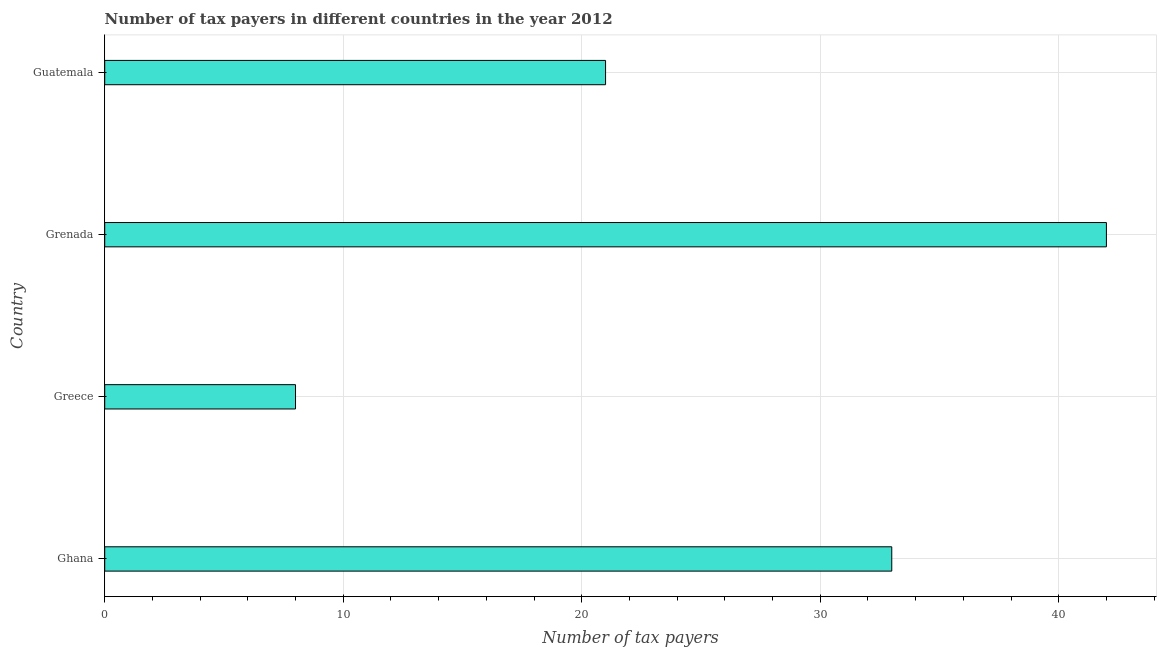What is the title of the graph?
Provide a short and direct response. Number of tax payers in different countries in the year 2012. What is the label or title of the X-axis?
Your response must be concise. Number of tax payers. What is the label or title of the Y-axis?
Provide a succinct answer. Country. In which country was the number of tax payers maximum?
Make the answer very short. Grenada. What is the sum of the number of tax payers?
Make the answer very short. 104. What is the average number of tax payers per country?
Offer a terse response. 26. What is the ratio of the number of tax payers in Ghana to that in Guatemala?
Make the answer very short. 1.57. Is the difference between the number of tax payers in Greece and Grenada greater than the difference between any two countries?
Your response must be concise. Yes. What is the difference between the highest and the second highest number of tax payers?
Your answer should be compact. 9. What is the difference between the highest and the lowest number of tax payers?
Provide a succinct answer. 34. Are all the bars in the graph horizontal?
Ensure brevity in your answer.  Yes. How many countries are there in the graph?
Provide a short and direct response. 4. What is the difference between two consecutive major ticks on the X-axis?
Your answer should be compact. 10. Are the values on the major ticks of X-axis written in scientific E-notation?
Offer a terse response. No. What is the Number of tax payers in Greece?
Your answer should be very brief. 8. What is the Number of tax payers in Guatemala?
Provide a succinct answer. 21. What is the difference between the Number of tax payers in Greece and Grenada?
Give a very brief answer. -34. What is the ratio of the Number of tax payers in Ghana to that in Greece?
Provide a short and direct response. 4.12. What is the ratio of the Number of tax payers in Ghana to that in Grenada?
Keep it short and to the point. 0.79. What is the ratio of the Number of tax payers in Ghana to that in Guatemala?
Give a very brief answer. 1.57. What is the ratio of the Number of tax payers in Greece to that in Grenada?
Your response must be concise. 0.19. What is the ratio of the Number of tax payers in Greece to that in Guatemala?
Your answer should be compact. 0.38. 